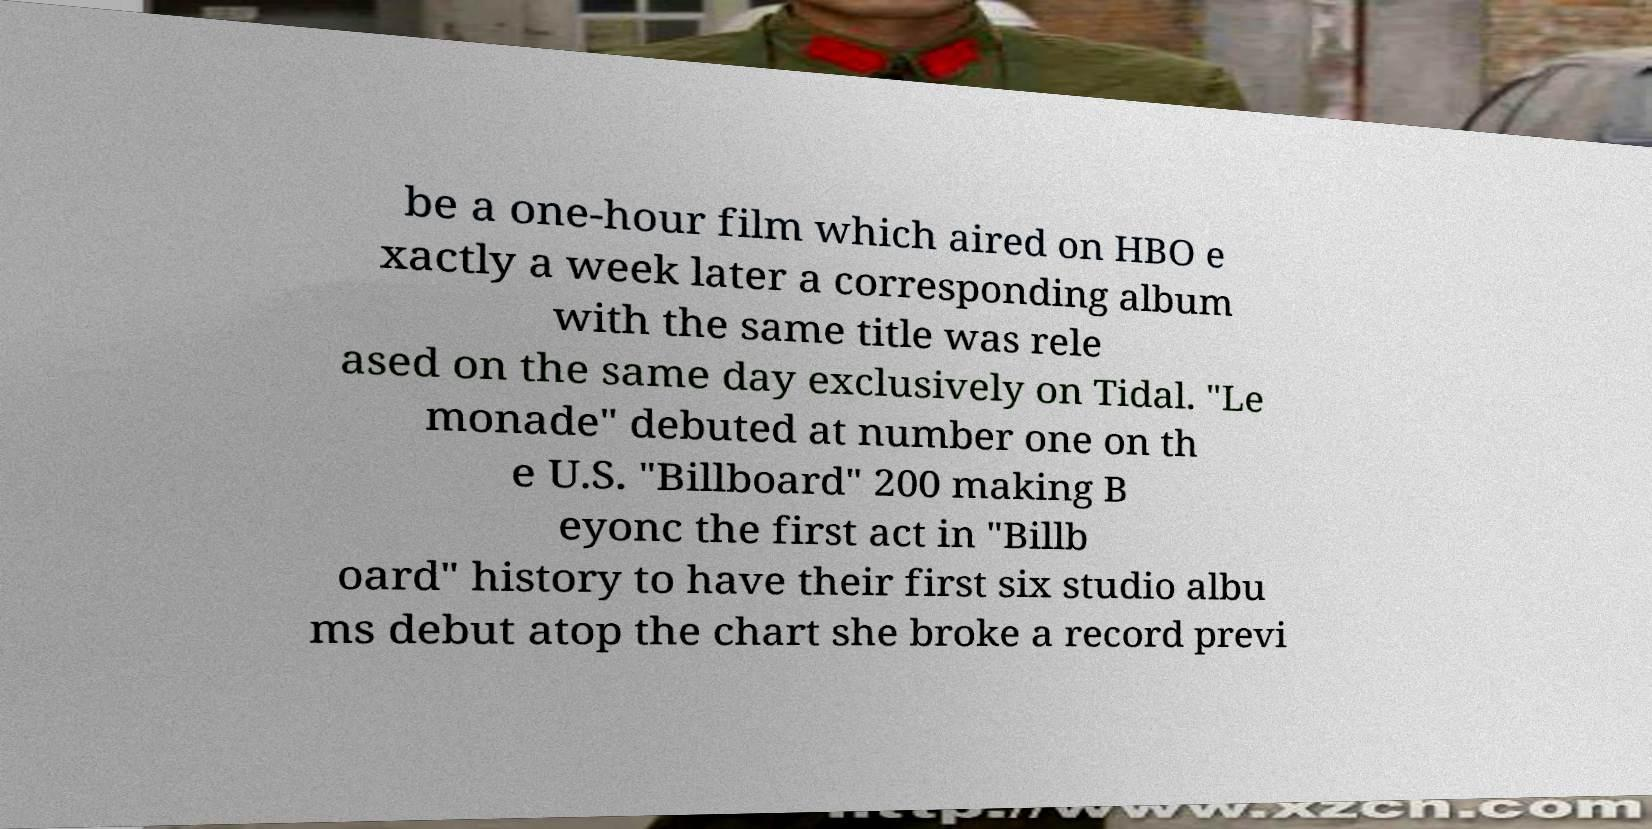Can you accurately transcribe the text from the provided image for me? be a one-hour film which aired on HBO e xactly a week later a corresponding album with the same title was rele ased on the same day exclusively on Tidal. "Le monade" debuted at number one on th e U.S. "Billboard" 200 making B eyonc the first act in "Billb oard" history to have their first six studio albu ms debut atop the chart she broke a record previ 